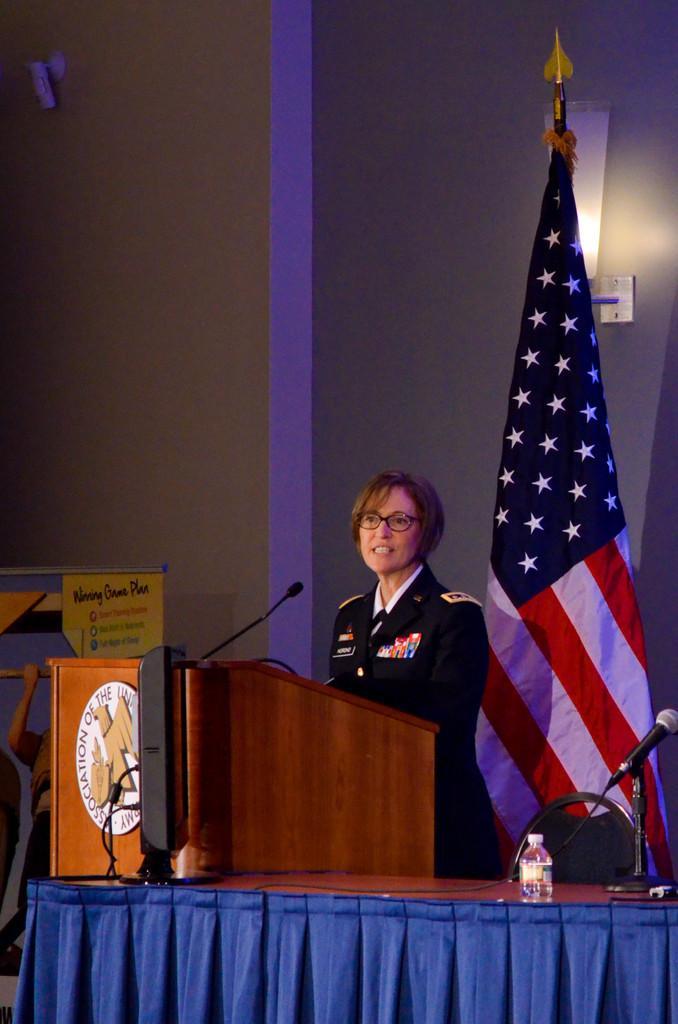Can you describe this image briefly? In this image, I can see a woman standing with clothes and spectacles. At the bottom of the image, I can see a table with a speaker, water bottle, mile and a cloth hanging. There is a name board attached to the wooden podium. On the right side of the image, I can see a flag hanging to a pole. In the background, there is a banner and a lamp attached to the wall. 